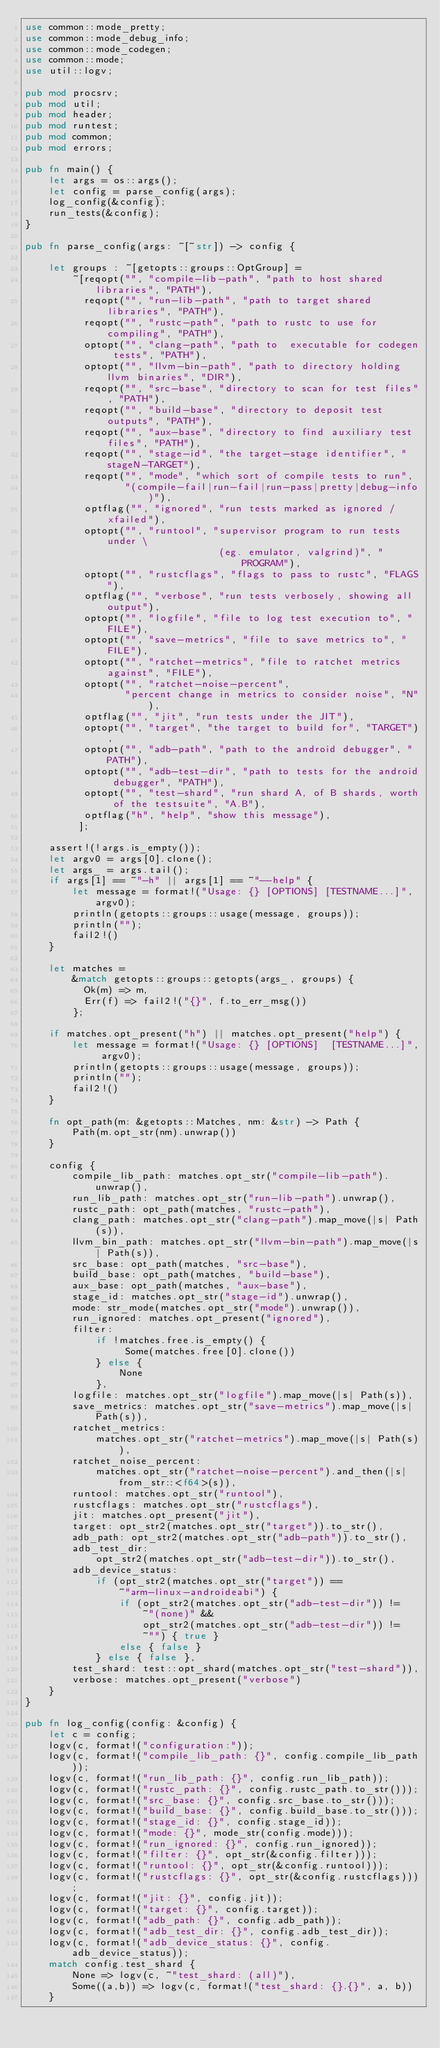Convert code to text. <code><loc_0><loc_0><loc_500><loc_500><_Rust_>use common::mode_pretty;
use common::mode_debug_info;
use common::mode_codegen;
use common::mode;
use util::logv;

pub mod procsrv;
pub mod util;
pub mod header;
pub mod runtest;
pub mod common;
pub mod errors;

pub fn main() {
    let args = os::args();
    let config = parse_config(args);
    log_config(&config);
    run_tests(&config);
}

pub fn parse_config(args: ~[~str]) -> config {

    let groups : ~[getopts::groups::OptGroup] =
        ~[reqopt("", "compile-lib-path", "path to host shared libraries", "PATH"),
          reqopt("", "run-lib-path", "path to target shared libraries", "PATH"),
          reqopt("", "rustc-path", "path to rustc to use for compiling", "PATH"),
          optopt("", "clang-path", "path to  executable for codegen tests", "PATH"),
          optopt("", "llvm-bin-path", "path to directory holding llvm binaries", "DIR"),
          reqopt("", "src-base", "directory to scan for test files", "PATH"),
          reqopt("", "build-base", "directory to deposit test outputs", "PATH"),
          reqopt("", "aux-base", "directory to find auxiliary test files", "PATH"),
          reqopt("", "stage-id", "the target-stage identifier", "stageN-TARGET"),
          reqopt("", "mode", "which sort of compile tests to run",
                 "(compile-fail|run-fail|run-pass|pretty|debug-info)"),
          optflag("", "ignored", "run tests marked as ignored / xfailed"),
          optopt("", "runtool", "supervisor program to run tests under \
                                 (eg. emulator, valgrind)", "PROGRAM"),
          optopt("", "rustcflags", "flags to pass to rustc", "FLAGS"),
          optflag("", "verbose", "run tests verbosely, showing all output"),
          optopt("", "logfile", "file to log test execution to", "FILE"),
          optopt("", "save-metrics", "file to save metrics to", "FILE"),
          optopt("", "ratchet-metrics", "file to ratchet metrics against", "FILE"),
          optopt("", "ratchet-noise-percent",
                 "percent change in metrics to consider noise", "N"),
          optflag("", "jit", "run tests under the JIT"),
          optopt("", "target", "the target to build for", "TARGET"),
          optopt("", "adb-path", "path to the android debugger", "PATH"),
          optopt("", "adb-test-dir", "path to tests for the android debugger", "PATH"),
          optopt("", "test-shard", "run shard A, of B shards, worth of the testsuite", "A.B"),
          optflag("h", "help", "show this message"),
         ];

    assert!(!args.is_empty());
    let argv0 = args[0].clone();
    let args_ = args.tail();
    if args[1] == ~"-h" || args[1] == ~"--help" {
        let message = format!("Usage: {} [OPTIONS] [TESTNAME...]", argv0);
        println(getopts::groups::usage(message, groups));
        println("");
        fail2!()
    }

    let matches =
        &match getopts::groups::getopts(args_, groups) {
          Ok(m) => m,
          Err(f) => fail2!("{}", f.to_err_msg())
        };

    if matches.opt_present("h") || matches.opt_present("help") {
        let message = format!("Usage: {} [OPTIONS]  [TESTNAME...]", argv0);
        println(getopts::groups::usage(message, groups));
        println("");
        fail2!()
    }

    fn opt_path(m: &getopts::Matches, nm: &str) -> Path {
        Path(m.opt_str(nm).unwrap())
    }

    config {
        compile_lib_path: matches.opt_str("compile-lib-path").unwrap(),
        run_lib_path: matches.opt_str("run-lib-path").unwrap(),
        rustc_path: opt_path(matches, "rustc-path"),
        clang_path: matches.opt_str("clang-path").map_move(|s| Path(s)),
        llvm_bin_path: matches.opt_str("llvm-bin-path").map_move(|s| Path(s)),
        src_base: opt_path(matches, "src-base"),
        build_base: opt_path(matches, "build-base"),
        aux_base: opt_path(matches, "aux-base"),
        stage_id: matches.opt_str("stage-id").unwrap(),
        mode: str_mode(matches.opt_str("mode").unwrap()),
        run_ignored: matches.opt_present("ignored"),
        filter:
            if !matches.free.is_empty() {
                 Some(matches.free[0].clone())
            } else {
                None
            },
        logfile: matches.opt_str("logfile").map_move(|s| Path(s)),
        save_metrics: matches.opt_str("save-metrics").map_move(|s| Path(s)),
        ratchet_metrics:
            matches.opt_str("ratchet-metrics").map_move(|s| Path(s)),
        ratchet_noise_percent:
            matches.opt_str("ratchet-noise-percent").and_then(|s| from_str::<f64>(s)),
        runtool: matches.opt_str("runtool"),
        rustcflags: matches.opt_str("rustcflags"),
        jit: matches.opt_present("jit"),
        target: opt_str2(matches.opt_str("target")).to_str(),
        adb_path: opt_str2(matches.opt_str("adb-path")).to_str(),
        adb_test_dir:
            opt_str2(matches.opt_str("adb-test-dir")).to_str(),
        adb_device_status:
            if (opt_str2(matches.opt_str("target")) ==
                ~"arm-linux-androideabi") {
                if (opt_str2(matches.opt_str("adb-test-dir")) !=
                    ~"(none)" &&
                    opt_str2(matches.opt_str("adb-test-dir")) !=
                    ~"") { true }
                else { false }
            } else { false },
        test_shard: test::opt_shard(matches.opt_str("test-shard")),
        verbose: matches.opt_present("verbose")
    }
}

pub fn log_config(config: &config) {
    let c = config;
    logv(c, format!("configuration:"));
    logv(c, format!("compile_lib_path: {}", config.compile_lib_path));
    logv(c, format!("run_lib_path: {}", config.run_lib_path));
    logv(c, format!("rustc_path: {}", config.rustc_path.to_str()));
    logv(c, format!("src_base: {}", config.src_base.to_str()));
    logv(c, format!("build_base: {}", config.build_base.to_str()));
    logv(c, format!("stage_id: {}", config.stage_id));
    logv(c, format!("mode: {}", mode_str(config.mode)));
    logv(c, format!("run_ignored: {}", config.run_ignored));
    logv(c, format!("filter: {}", opt_str(&config.filter)));
    logv(c, format!("runtool: {}", opt_str(&config.runtool)));
    logv(c, format!("rustcflags: {}", opt_str(&config.rustcflags)));
    logv(c, format!("jit: {}", config.jit));
    logv(c, format!("target: {}", config.target));
    logv(c, format!("adb_path: {}", config.adb_path));
    logv(c, format!("adb_test_dir: {}", config.adb_test_dir));
    logv(c, format!("adb_device_status: {}", config.adb_device_status));
    match config.test_shard {
        None => logv(c, ~"test_shard: (all)"),
        Some((a,b)) => logv(c, format!("test_shard: {}.{}", a, b))
    }</code> 